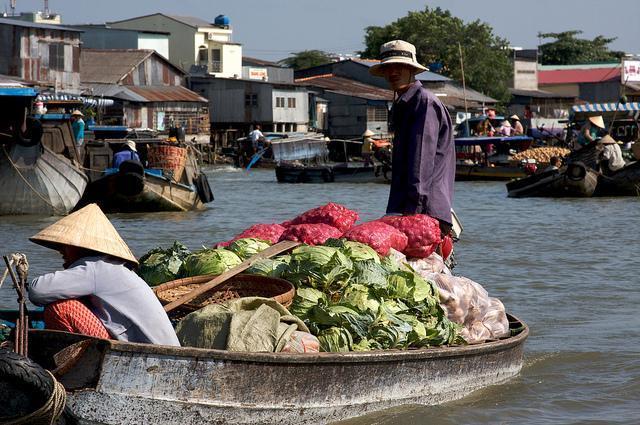How many red bags are there?
Give a very brief answer. 5. How many boats are there?
Give a very brief answer. 5. How many people can you see?
Give a very brief answer. 2. 